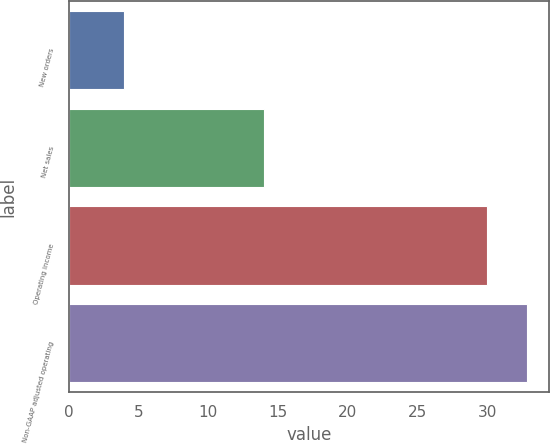Convert chart. <chart><loc_0><loc_0><loc_500><loc_500><bar_chart><fcel>New orders<fcel>Net sales<fcel>Operating income<fcel>Non-GAAP adjusted operating<nl><fcel>4<fcel>14<fcel>30<fcel>32.8<nl></chart> 